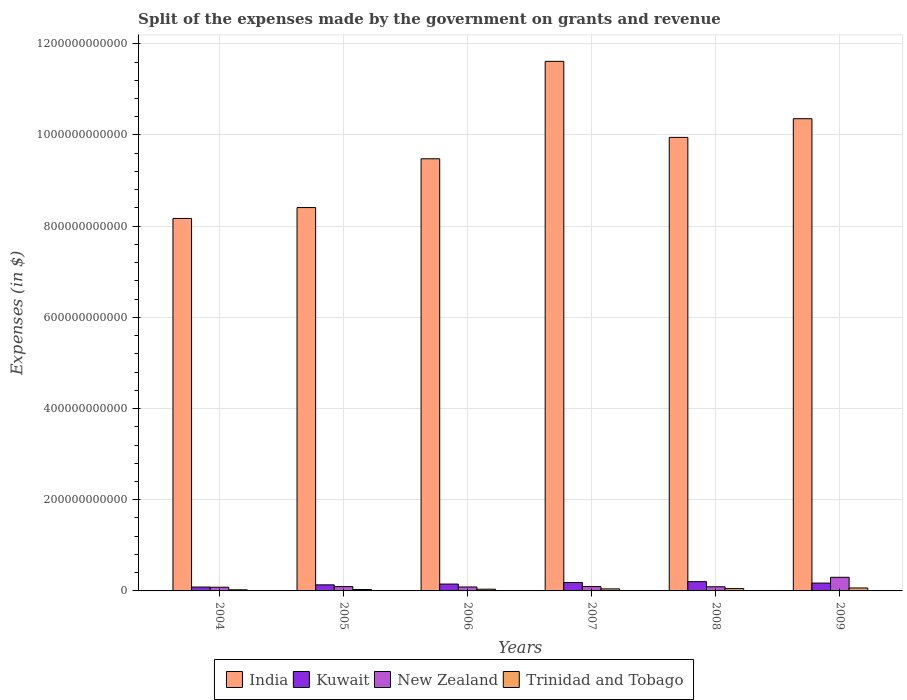How many groups of bars are there?
Provide a short and direct response. 6. How many bars are there on the 1st tick from the left?
Your answer should be very brief. 4. In how many cases, is the number of bars for a given year not equal to the number of legend labels?
Your response must be concise. 0. What is the expenses made by the government on grants and revenue in Kuwait in 2009?
Your answer should be very brief. 1.72e+1. Across all years, what is the maximum expenses made by the government on grants and revenue in India?
Your answer should be compact. 1.16e+12. Across all years, what is the minimum expenses made by the government on grants and revenue in Trinidad and Tobago?
Provide a short and direct response. 2.43e+09. In which year was the expenses made by the government on grants and revenue in Kuwait minimum?
Provide a succinct answer. 2004. What is the total expenses made by the government on grants and revenue in India in the graph?
Ensure brevity in your answer.  5.80e+12. What is the difference between the expenses made by the government on grants and revenue in New Zealand in 2005 and that in 2007?
Your answer should be compact. -1.03e+08. What is the difference between the expenses made by the government on grants and revenue in Kuwait in 2008 and the expenses made by the government on grants and revenue in India in 2009?
Offer a terse response. -1.02e+12. What is the average expenses made by the government on grants and revenue in India per year?
Ensure brevity in your answer.  9.66e+11. In the year 2004, what is the difference between the expenses made by the government on grants and revenue in Trinidad and Tobago and expenses made by the government on grants and revenue in India?
Offer a very short reply. -8.14e+11. What is the ratio of the expenses made by the government on grants and revenue in Trinidad and Tobago in 2005 to that in 2008?
Your response must be concise. 0.6. Is the difference between the expenses made by the government on grants and revenue in Trinidad and Tobago in 2004 and 2009 greater than the difference between the expenses made by the government on grants and revenue in India in 2004 and 2009?
Keep it short and to the point. Yes. What is the difference between the highest and the second highest expenses made by the government on grants and revenue in Kuwait?
Your response must be concise. 1.98e+09. What is the difference between the highest and the lowest expenses made by the government on grants and revenue in Kuwait?
Give a very brief answer. 1.19e+1. In how many years, is the expenses made by the government on grants and revenue in Kuwait greater than the average expenses made by the government on grants and revenue in Kuwait taken over all years?
Your response must be concise. 3. Is the sum of the expenses made by the government on grants and revenue in New Zealand in 2005 and 2008 greater than the maximum expenses made by the government on grants and revenue in India across all years?
Offer a terse response. No. Is it the case that in every year, the sum of the expenses made by the government on grants and revenue in Kuwait and expenses made by the government on grants and revenue in India is greater than the sum of expenses made by the government on grants and revenue in New Zealand and expenses made by the government on grants and revenue in Trinidad and Tobago?
Your response must be concise. No. What does the 2nd bar from the left in 2006 represents?
Give a very brief answer. Kuwait. What does the 2nd bar from the right in 2006 represents?
Offer a very short reply. New Zealand. What is the difference between two consecutive major ticks on the Y-axis?
Provide a short and direct response. 2.00e+11. Does the graph contain any zero values?
Offer a very short reply. No. Does the graph contain grids?
Keep it short and to the point. Yes. Where does the legend appear in the graph?
Give a very brief answer. Bottom center. What is the title of the graph?
Give a very brief answer. Split of the expenses made by the government on grants and revenue. Does "Netherlands" appear as one of the legend labels in the graph?
Offer a terse response. No. What is the label or title of the Y-axis?
Your answer should be very brief. Expenses (in $). What is the Expenses (in $) of India in 2004?
Provide a succinct answer. 8.17e+11. What is the Expenses (in $) in Kuwait in 2004?
Give a very brief answer. 8.50e+09. What is the Expenses (in $) in New Zealand in 2004?
Provide a succinct answer. 8.09e+09. What is the Expenses (in $) in Trinidad and Tobago in 2004?
Your answer should be very brief. 2.43e+09. What is the Expenses (in $) in India in 2005?
Offer a terse response. 8.41e+11. What is the Expenses (in $) of Kuwait in 2005?
Give a very brief answer. 1.33e+1. What is the Expenses (in $) in New Zealand in 2005?
Your response must be concise. 9.45e+09. What is the Expenses (in $) of Trinidad and Tobago in 2005?
Offer a terse response. 3.06e+09. What is the Expenses (in $) of India in 2006?
Keep it short and to the point. 9.48e+11. What is the Expenses (in $) of Kuwait in 2006?
Provide a succinct answer. 1.50e+1. What is the Expenses (in $) of New Zealand in 2006?
Give a very brief answer. 8.64e+09. What is the Expenses (in $) in Trinidad and Tobago in 2006?
Give a very brief answer. 3.79e+09. What is the Expenses (in $) in India in 2007?
Your response must be concise. 1.16e+12. What is the Expenses (in $) of Kuwait in 2007?
Your answer should be very brief. 1.84e+1. What is the Expenses (in $) of New Zealand in 2007?
Offer a terse response. 9.55e+09. What is the Expenses (in $) of Trinidad and Tobago in 2007?
Your response must be concise. 4.42e+09. What is the Expenses (in $) of India in 2008?
Offer a terse response. 9.95e+11. What is the Expenses (in $) in Kuwait in 2008?
Offer a terse response. 2.04e+1. What is the Expenses (in $) of New Zealand in 2008?
Your answer should be very brief. 9.06e+09. What is the Expenses (in $) of Trinidad and Tobago in 2008?
Provide a succinct answer. 5.11e+09. What is the Expenses (in $) in India in 2009?
Your answer should be very brief. 1.04e+12. What is the Expenses (in $) in Kuwait in 2009?
Offer a very short reply. 1.72e+1. What is the Expenses (in $) in New Zealand in 2009?
Provide a succinct answer. 2.99e+1. What is the Expenses (in $) in Trinidad and Tobago in 2009?
Make the answer very short. 6.45e+09. Across all years, what is the maximum Expenses (in $) of India?
Your answer should be very brief. 1.16e+12. Across all years, what is the maximum Expenses (in $) of Kuwait?
Make the answer very short. 2.04e+1. Across all years, what is the maximum Expenses (in $) in New Zealand?
Your response must be concise. 2.99e+1. Across all years, what is the maximum Expenses (in $) of Trinidad and Tobago?
Provide a short and direct response. 6.45e+09. Across all years, what is the minimum Expenses (in $) of India?
Your response must be concise. 8.17e+11. Across all years, what is the minimum Expenses (in $) of Kuwait?
Your answer should be compact. 8.50e+09. Across all years, what is the minimum Expenses (in $) of New Zealand?
Your response must be concise. 8.09e+09. Across all years, what is the minimum Expenses (in $) of Trinidad and Tobago?
Keep it short and to the point. 2.43e+09. What is the total Expenses (in $) in India in the graph?
Your answer should be compact. 5.80e+12. What is the total Expenses (in $) of Kuwait in the graph?
Keep it short and to the point. 9.28e+1. What is the total Expenses (in $) of New Zealand in the graph?
Your response must be concise. 7.46e+1. What is the total Expenses (in $) in Trinidad and Tobago in the graph?
Provide a succinct answer. 2.53e+1. What is the difference between the Expenses (in $) in India in 2004 and that in 2005?
Your answer should be compact. -2.38e+1. What is the difference between the Expenses (in $) of Kuwait in 2004 and that in 2005?
Your response must be concise. -4.81e+09. What is the difference between the Expenses (in $) in New Zealand in 2004 and that in 2005?
Offer a very short reply. -1.36e+09. What is the difference between the Expenses (in $) in Trinidad and Tobago in 2004 and that in 2005?
Offer a terse response. -6.26e+08. What is the difference between the Expenses (in $) in India in 2004 and that in 2006?
Provide a short and direct response. -1.31e+11. What is the difference between the Expenses (in $) in Kuwait in 2004 and that in 2006?
Your answer should be very brief. -6.51e+09. What is the difference between the Expenses (in $) of New Zealand in 2004 and that in 2006?
Provide a short and direct response. -5.56e+08. What is the difference between the Expenses (in $) of Trinidad and Tobago in 2004 and that in 2006?
Keep it short and to the point. -1.36e+09. What is the difference between the Expenses (in $) of India in 2004 and that in 2007?
Offer a terse response. -3.45e+11. What is the difference between the Expenses (in $) in Kuwait in 2004 and that in 2007?
Offer a very short reply. -9.89e+09. What is the difference between the Expenses (in $) in New Zealand in 2004 and that in 2007?
Your response must be concise. -1.46e+09. What is the difference between the Expenses (in $) of Trinidad and Tobago in 2004 and that in 2007?
Make the answer very short. -1.99e+09. What is the difference between the Expenses (in $) of India in 2004 and that in 2008?
Ensure brevity in your answer.  -1.78e+11. What is the difference between the Expenses (in $) in Kuwait in 2004 and that in 2008?
Make the answer very short. -1.19e+1. What is the difference between the Expenses (in $) in New Zealand in 2004 and that in 2008?
Keep it short and to the point. -9.72e+08. What is the difference between the Expenses (in $) in Trinidad and Tobago in 2004 and that in 2008?
Ensure brevity in your answer.  -2.68e+09. What is the difference between the Expenses (in $) in India in 2004 and that in 2009?
Provide a short and direct response. -2.19e+11. What is the difference between the Expenses (in $) in Kuwait in 2004 and that in 2009?
Offer a terse response. -8.67e+09. What is the difference between the Expenses (in $) in New Zealand in 2004 and that in 2009?
Make the answer very short. -2.18e+1. What is the difference between the Expenses (in $) in Trinidad and Tobago in 2004 and that in 2009?
Provide a short and direct response. -4.02e+09. What is the difference between the Expenses (in $) in India in 2005 and that in 2006?
Your answer should be compact. -1.07e+11. What is the difference between the Expenses (in $) of Kuwait in 2005 and that in 2006?
Offer a very short reply. -1.70e+09. What is the difference between the Expenses (in $) in New Zealand in 2005 and that in 2006?
Your response must be concise. 8.05e+08. What is the difference between the Expenses (in $) in Trinidad and Tobago in 2005 and that in 2006?
Provide a succinct answer. -7.30e+08. What is the difference between the Expenses (in $) in India in 2005 and that in 2007?
Give a very brief answer. -3.21e+11. What is the difference between the Expenses (in $) in Kuwait in 2005 and that in 2007?
Your response must be concise. -5.08e+09. What is the difference between the Expenses (in $) of New Zealand in 2005 and that in 2007?
Offer a terse response. -1.03e+08. What is the difference between the Expenses (in $) of Trinidad and Tobago in 2005 and that in 2007?
Make the answer very short. -1.36e+09. What is the difference between the Expenses (in $) of India in 2005 and that in 2008?
Offer a very short reply. -1.54e+11. What is the difference between the Expenses (in $) in Kuwait in 2005 and that in 2008?
Make the answer very short. -7.06e+09. What is the difference between the Expenses (in $) of New Zealand in 2005 and that in 2008?
Ensure brevity in your answer.  3.89e+08. What is the difference between the Expenses (in $) in Trinidad and Tobago in 2005 and that in 2008?
Provide a succinct answer. -2.05e+09. What is the difference between the Expenses (in $) of India in 2005 and that in 2009?
Provide a short and direct response. -1.95e+11. What is the difference between the Expenses (in $) in Kuwait in 2005 and that in 2009?
Make the answer very short. -3.86e+09. What is the difference between the Expenses (in $) in New Zealand in 2005 and that in 2009?
Offer a very short reply. -2.04e+1. What is the difference between the Expenses (in $) of Trinidad and Tobago in 2005 and that in 2009?
Offer a very short reply. -3.40e+09. What is the difference between the Expenses (in $) of India in 2006 and that in 2007?
Your answer should be compact. -2.14e+11. What is the difference between the Expenses (in $) in Kuwait in 2006 and that in 2007?
Your response must be concise. -3.38e+09. What is the difference between the Expenses (in $) of New Zealand in 2006 and that in 2007?
Offer a terse response. -9.08e+08. What is the difference between the Expenses (in $) of Trinidad and Tobago in 2006 and that in 2007?
Provide a short and direct response. -6.34e+08. What is the difference between the Expenses (in $) in India in 2006 and that in 2008?
Provide a short and direct response. -4.69e+1. What is the difference between the Expenses (in $) in Kuwait in 2006 and that in 2008?
Your answer should be very brief. -5.36e+09. What is the difference between the Expenses (in $) of New Zealand in 2006 and that in 2008?
Your response must be concise. -4.16e+08. What is the difference between the Expenses (in $) in Trinidad and Tobago in 2006 and that in 2008?
Offer a very short reply. -1.32e+09. What is the difference between the Expenses (in $) of India in 2006 and that in 2009?
Your answer should be compact. -8.79e+1. What is the difference between the Expenses (in $) of Kuwait in 2006 and that in 2009?
Your answer should be very brief. -2.16e+09. What is the difference between the Expenses (in $) of New Zealand in 2006 and that in 2009?
Your response must be concise. -2.12e+1. What is the difference between the Expenses (in $) in Trinidad and Tobago in 2006 and that in 2009?
Your response must be concise. -2.66e+09. What is the difference between the Expenses (in $) of India in 2007 and that in 2008?
Your answer should be compact. 1.67e+11. What is the difference between the Expenses (in $) of Kuwait in 2007 and that in 2008?
Provide a succinct answer. -1.98e+09. What is the difference between the Expenses (in $) of New Zealand in 2007 and that in 2008?
Your response must be concise. 4.92e+08. What is the difference between the Expenses (in $) in Trinidad and Tobago in 2007 and that in 2008?
Offer a terse response. -6.86e+08. What is the difference between the Expenses (in $) of India in 2007 and that in 2009?
Make the answer very short. 1.26e+11. What is the difference between the Expenses (in $) of Kuwait in 2007 and that in 2009?
Ensure brevity in your answer.  1.22e+09. What is the difference between the Expenses (in $) in New Zealand in 2007 and that in 2009?
Offer a terse response. -2.03e+1. What is the difference between the Expenses (in $) of Trinidad and Tobago in 2007 and that in 2009?
Ensure brevity in your answer.  -2.03e+09. What is the difference between the Expenses (in $) of India in 2008 and that in 2009?
Ensure brevity in your answer.  -4.10e+1. What is the difference between the Expenses (in $) in Kuwait in 2008 and that in 2009?
Keep it short and to the point. 3.20e+09. What is the difference between the Expenses (in $) of New Zealand in 2008 and that in 2009?
Your answer should be compact. -2.08e+1. What is the difference between the Expenses (in $) of Trinidad and Tobago in 2008 and that in 2009?
Keep it short and to the point. -1.34e+09. What is the difference between the Expenses (in $) of India in 2004 and the Expenses (in $) of Kuwait in 2005?
Your answer should be very brief. 8.04e+11. What is the difference between the Expenses (in $) of India in 2004 and the Expenses (in $) of New Zealand in 2005?
Give a very brief answer. 8.07e+11. What is the difference between the Expenses (in $) of India in 2004 and the Expenses (in $) of Trinidad and Tobago in 2005?
Provide a succinct answer. 8.14e+11. What is the difference between the Expenses (in $) of Kuwait in 2004 and the Expenses (in $) of New Zealand in 2005?
Make the answer very short. -9.43e+08. What is the difference between the Expenses (in $) of Kuwait in 2004 and the Expenses (in $) of Trinidad and Tobago in 2005?
Ensure brevity in your answer.  5.45e+09. What is the difference between the Expenses (in $) in New Zealand in 2004 and the Expenses (in $) in Trinidad and Tobago in 2005?
Offer a terse response. 5.03e+09. What is the difference between the Expenses (in $) in India in 2004 and the Expenses (in $) in Kuwait in 2006?
Provide a short and direct response. 8.02e+11. What is the difference between the Expenses (in $) in India in 2004 and the Expenses (in $) in New Zealand in 2006?
Make the answer very short. 8.08e+11. What is the difference between the Expenses (in $) in India in 2004 and the Expenses (in $) in Trinidad and Tobago in 2006?
Your response must be concise. 8.13e+11. What is the difference between the Expenses (in $) of Kuwait in 2004 and the Expenses (in $) of New Zealand in 2006?
Provide a short and direct response. -1.38e+08. What is the difference between the Expenses (in $) of Kuwait in 2004 and the Expenses (in $) of Trinidad and Tobago in 2006?
Ensure brevity in your answer.  4.71e+09. What is the difference between the Expenses (in $) in New Zealand in 2004 and the Expenses (in $) in Trinidad and Tobago in 2006?
Ensure brevity in your answer.  4.30e+09. What is the difference between the Expenses (in $) in India in 2004 and the Expenses (in $) in Kuwait in 2007?
Your answer should be very brief. 7.99e+11. What is the difference between the Expenses (in $) in India in 2004 and the Expenses (in $) in New Zealand in 2007?
Ensure brevity in your answer.  8.07e+11. What is the difference between the Expenses (in $) in India in 2004 and the Expenses (in $) in Trinidad and Tobago in 2007?
Your response must be concise. 8.12e+11. What is the difference between the Expenses (in $) in Kuwait in 2004 and the Expenses (in $) in New Zealand in 2007?
Offer a very short reply. -1.05e+09. What is the difference between the Expenses (in $) of Kuwait in 2004 and the Expenses (in $) of Trinidad and Tobago in 2007?
Your answer should be very brief. 4.08e+09. What is the difference between the Expenses (in $) in New Zealand in 2004 and the Expenses (in $) in Trinidad and Tobago in 2007?
Ensure brevity in your answer.  3.66e+09. What is the difference between the Expenses (in $) of India in 2004 and the Expenses (in $) of Kuwait in 2008?
Your response must be concise. 7.97e+11. What is the difference between the Expenses (in $) in India in 2004 and the Expenses (in $) in New Zealand in 2008?
Give a very brief answer. 8.08e+11. What is the difference between the Expenses (in $) of India in 2004 and the Expenses (in $) of Trinidad and Tobago in 2008?
Give a very brief answer. 8.12e+11. What is the difference between the Expenses (in $) of Kuwait in 2004 and the Expenses (in $) of New Zealand in 2008?
Offer a terse response. -5.54e+08. What is the difference between the Expenses (in $) in Kuwait in 2004 and the Expenses (in $) in Trinidad and Tobago in 2008?
Provide a short and direct response. 3.39e+09. What is the difference between the Expenses (in $) of New Zealand in 2004 and the Expenses (in $) of Trinidad and Tobago in 2008?
Keep it short and to the point. 2.98e+09. What is the difference between the Expenses (in $) of India in 2004 and the Expenses (in $) of Kuwait in 2009?
Ensure brevity in your answer.  8.00e+11. What is the difference between the Expenses (in $) in India in 2004 and the Expenses (in $) in New Zealand in 2009?
Give a very brief answer. 7.87e+11. What is the difference between the Expenses (in $) in India in 2004 and the Expenses (in $) in Trinidad and Tobago in 2009?
Provide a short and direct response. 8.10e+11. What is the difference between the Expenses (in $) in Kuwait in 2004 and the Expenses (in $) in New Zealand in 2009?
Offer a terse response. -2.14e+1. What is the difference between the Expenses (in $) in Kuwait in 2004 and the Expenses (in $) in Trinidad and Tobago in 2009?
Give a very brief answer. 2.05e+09. What is the difference between the Expenses (in $) of New Zealand in 2004 and the Expenses (in $) of Trinidad and Tobago in 2009?
Offer a terse response. 1.63e+09. What is the difference between the Expenses (in $) in India in 2005 and the Expenses (in $) in Kuwait in 2006?
Make the answer very short. 8.26e+11. What is the difference between the Expenses (in $) of India in 2005 and the Expenses (in $) of New Zealand in 2006?
Provide a succinct answer. 8.32e+11. What is the difference between the Expenses (in $) of India in 2005 and the Expenses (in $) of Trinidad and Tobago in 2006?
Your answer should be very brief. 8.37e+11. What is the difference between the Expenses (in $) of Kuwait in 2005 and the Expenses (in $) of New Zealand in 2006?
Ensure brevity in your answer.  4.67e+09. What is the difference between the Expenses (in $) in Kuwait in 2005 and the Expenses (in $) in Trinidad and Tobago in 2006?
Give a very brief answer. 9.52e+09. What is the difference between the Expenses (in $) of New Zealand in 2005 and the Expenses (in $) of Trinidad and Tobago in 2006?
Your answer should be very brief. 5.66e+09. What is the difference between the Expenses (in $) in India in 2005 and the Expenses (in $) in Kuwait in 2007?
Your answer should be compact. 8.22e+11. What is the difference between the Expenses (in $) in India in 2005 and the Expenses (in $) in New Zealand in 2007?
Your answer should be very brief. 8.31e+11. What is the difference between the Expenses (in $) of India in 2005 and the Expenses (in $) of Trinidad and Tobago in 2007?
Make the answer very short. 8.36e+11. What is the difference between the Expenses (in $) in Kuwait in 2005 and the Expenses (in $) in New Zealand in 2007?
Your answer should be very brief. 3.76e+09. What is the difference between the Expenses (in $) of Kuwait in 2005 and the Expenses (in $) of Trinidad and Tobago in 2007?
Keep it short and to the point. 8.89e+09. What is the difference between the Expenses (in $) in New Zealand in 2005 and the Expenses (in $) in Trinidad and Tobago in 2007?
Provide a succinct answer. 5.02e+09. What is the difference between the Expenses (in $) in India in 2005 and the Expenses (in $) in Kuwait in 2008?
Provide a short and direct response. 8.20e+11. What is the difference between the Expenses (in $) of India in 2005 and the Expenses (in $) of New Zealand in 2008?
Your answer should be very brief. 8.32e+11. What is the difference between the Expenses (in $) in India in 2005 and the Expenses (in $) in Trinidad and Tobago in 2008?
Keep it short and to the point. 8.36e+11. What is the difference between the Expenses (in $) of Kuwait in 2005 and the Expenses (in $) of New Zealand in 2008?
Your answer should be very brief. 4.26e+09. What is the difference between the Expenses (in $) of Kuwait in 2005 and the Expenses (in $) of Trinidad and Tobago in 2008?
Provide a succinct answer. 8.20e+09. What is the difference between the Expenses (in $) in New Zealand in 2005 and the Expenses (in $) in Trinidad and Tobago in 2008?
Your answer should be very brief. 4.34e+09. What is the difference between the Expenses (in $) of India in 2005 and the Expenses (in $) of Kuwait in 2009?
Offer a terse response. 8.24e+11. What is the difference between the Expenses (in $) in India in 2005 and the Expenses (in $) in New Zealand in 2009?
Offer a very short reply. 8.11e+11. What is the difference between the Expenses (in $) of India in 2005 and the Expenses (in $) of Trinidad and Tobago in 2009?
Make the answer very short. 8.34e+11. What is the difference between the Expenses (in $) of Kuwait in 2005 and the Expenses (in $) of New Zealand in 2009?
Your answer should be compact. -1.65e+1. What is the difference between the Expenses (in $) in Kuwait in 2005 and the Expenses (in $) in Trinidad and Tobago in 2009?
Your answer should be compact. 6.86e+09. What is the difference between the Expenses (in $) in New Zealand in 2005 and the Expenses (in $) in Trinidad and Tobago in 2009?
Offer a very short reply. 2.99e+09. What is the difference between the Expenses (in $) of India in 2006 and the Expenses (in $) of Kuwait in 2007?
Provide a short and direct response. 9.29e+11. What is the difference between the Expenses (in $) of India in 2006 and the Expenses (in $) of New Zealand in 2007?
Offer a terse response. 9.38e+11. What is the difference between the Expenses (in $) of India in 2006 and the Expenses (in $) of Trinidad and Tobago in 2007?
Offer a terse response. 9.43e+11. What is the difference between the Expenses (in $) in Kuwait in 2006 and the Expenses (in $) in New Zealand in 2007?
Make the answer very short. 5.47e+09. What is the difference between the Expenses (in $) of Kuwait in 2006 and the Expenses (in $) of Trinidad and Tobago in 2007?
Keep it short and to the point. 1.06e+1. What is the difference between the Expenses (in $) of New Zealand in 2006 and the Expenses (in $) of Trinidad and Tobago in 2007?
Provide a short and direct response. 4.22e+09. What is the difference between the Expenses (in $) in India in 2006 and the Expenses (in $) in Kuwait in 2008?
Keep it short and to the point. 9.27e+11. What is the difference between the Expenses (in $) of India in 2006 and the Expenses (in $) of New Zealand in 2008?
Ensure brevity in your answer.  9.39e+11. What is the difference between the Expenses (in $) in India in 2006 and the Expenses (in $) in Trinidad and Tobago in 2008?
Provide a short and direct response. 9.43e+11. What is the difference between the Expenses (in $) in Kuwait in 2006 and the Expenses (in $) in New Zealand in 2008?
Make the answer very short. 5.96e+09. What is the difference between the Expenses (in $) in Kuwait in 2006 and the Expenses (in $) in Trinidad and Tobago in 2008?
Your answer should be compact. 9.91e+09. What is the difference between the Expenses (in $) of New Zealand in 2006 and the Expenses (in $) of Trinidad and Tobago in 2008?
Keep it short and to the point. 3.53e+09. What is the difference between the Expenses (in $) in India in 2006 and the Expenses (in $) in Kuwait in 2009?
Give a very brief answer. 9.31e+11. What is the difference between the Expenses (in $) in India in 2006 and the Expenses (in $) in New Zealand in 2009?
Make the answer very short. 9.18e+11. What is the difference between the Expenses (in $) of India in 2006 and the Expenses (in $) of Trinidad and Tobago in 2009?
Provide a short and direct response. 9.41e+11. What is the difference between the Expenses (in $) of Kuwait in 2006 and the Expenses (in $) of New Zealand in 2009?
Your answer should be very brief. -1.48e+1. What is the difference between the Expenses (in $) in Kuwait in 2006 and the Expenses (in $) in Trinidad and Tobago in 2009?
Your response must be concise. 8.56e+09. What is the difference between the Expenses (in $) in New Zealand in 2006 and the Expenses (in $) in Trinidad and Tobago in 2009?
Ensure brevity in your answer.  2.19e+09. What is the difference between the Expenses (in $) of India in 2007 and the Expenses (in $) of Kuwait in 2008?
Keep it short and to the point. 1.14e+12. What is the difference between the Expenses (in $) of India in 2007 and the Expenses (in $) of New Zealand in 2008?
Keep it short and to the point. 1.15e+12. What is the difference between the Expenses (in $) in India in 2007 and the Expenses (in $) in Trinidad and Tobago in 2008?
Provide a succinct answer. 1.16e+12. What is the difference between the Expenses (in $) of Kuwait in 2007 and the Expenses (in $) of New Zealand in 2008?
Provide a short and direct response. 9.33e+09. What is the difference between the Expenses (in $) in Kuwait in 2007 and the Expenses (in $) in Trinidad and Tobago in 2008?
Your response must be concise. 1.33e+1. What is the difference between the Expenses (in $) in New Zealand in 2007 and the Expenses (in $) in Trinidad and Tobago in 2008?
Your response must be concise. 4.44e+09. What is the difference between the Expenses (in $) of India in 2007 and the Expenses (in $) of Kuwait in 2009?
Provide a succinct answer. 1.14e+12. What is the difference between the Expenses (in $) in India in 2007 and the Expenses (in $) in New Zealand in 2009?
Make the answer very short. 1.13e+12. What is the difference between the Expenses (in $) of India in 2007 and the Expenses (in $) of Trinidad and Tobago in 2009?
Provide a short and direct response. 1.15e+12. What is the difference between the Expenses (in $) in Kuwait in 2007 and the Expenses (in $) in New Zealand in 2009?
Make the answer very short. -1.15e+1. What is the difference between the Expenses (in $) in Kuwait in 2007 and the Expenses (in $) in Trinidad and Tobago in 2009?
Ensure brevity in your answer.  1.19e+1. What is the difference between the Expenses (in $) in New Zealand in 2007 and the Expenses (in $) in Trinidad and Tobago in 2009?
Ensure brevity in your answer.  3.10e+09. What is the difference between the Expenses (in $) in India in 2008 and the Expenses (in $) in Kuwait in 2009?
Your response must be concise. 9.77e+11. What is the difference between the Expenses (in $) in India in 2008 and the Expenses (in $) in New Zealand in 2009?
Keep it short and to the point. 9.65e+11. What is the difference between the Expenses (in $) in India in 2008 and the Expenses (in $) in Trinidad and Tobago in 2009?
Your answer should be very brief. 9.88e+11. What is the difference between the Expenses (in $) of Kuwait in 2008 and the Expenses (in $) of New Zealand in 2009?
Offer a very short reply. -9.48e+09. What is the difference between the Expenses (in $) of Kuwait in 2008 and the Expenses (in $) of Trinidad and Tobago in 2009?
Offer a very short reply. 1.39e+1. What is the difference between the Expenses (in $) in New Zealand in 2008 and the Expenses (in $) in Trinidad and Tobago in 2009?
Your answer should be very brief. 2.60e+09. What is the average Expenses (in $) in India per year?
Offer a terse response. 9.66e+11. What is the average Expenses (in $) of Kuwait per year?
Your answer should be very brief. 1.55e+1. What is the average Expenses (in $) in New Zealand per year?
Offer a terse response. 1.24e+1. What is the average Expenses (in $) of Trinidad and Tobago per year?
Offer a terse response. 4.21e+09. In the year 2004, what is the difference between the Expenses (in $) of India and Expenses (in $) of Kuwait?
Offer a terse response. 8.08e+11. In the year 2004, what is the difference between the Expenses (in $) of India and Expenses (in $) of New Zealand?
Keep it short and to the point. 8.09e+11. In the year 2004, what is the difference between the Expenses (in $) of India and Expenses (in $) of Trinidad and Tobago?
Offer a very short reply. 8.14e+11. In the year 2004, what is the difference between the Expenses (in $) of Kuwait and Expenses (in $) of New Zealand?
Your response must be concise. 4.18e+08. In the year 2004, what is the difference between the Expenses (in $) in Kuwait and Expenses (in $) in Trinidad and Tobago?
Keep it short and to the point. 6.07e+09. In the year 2004, what is the difference between the Expenses (in $) of New Zealand and Expenses (in $) of Trinidad and Tobago?
Offer a terse response. 5.65e+09. In the year 2005, what is the difference between the Expenses (in $) in India and Expenses (in $) in Kuwait?
Your answer should be very brief. 8.27e+11. In the year 2005, what is the difference between the Expenses (in $) of India and Expenses (in $) of New Zealand?
Keep it short and to the point. 8.31e+11. In the year 2005, what is the difference between the Expenses (in $) in India and Expenses (in $) in Trinidad and Tobago?
Make the answer very short. 8.38e+11. In the year 2005, what is the difference between the Expenses (in $) in Kuwait and Expenses (in $) in New Zealand?
Ensure brevity in your answer.  3.87e+09. In the year 2005, what is the difference between the Expenses (in $) in Kuwait and Expenses (in $) in Trinidad and Tobago?
Keep it short and to the point. 1.03e+1. In the year 2005, what is the difference between the Expenses (in $) of New Zealand and Expenses (in $) of Trinidad and Tobago?
Make the answer very short. 6.39e+09. In the year 2006, what is the difference between the Expenses (in $) in India and Expenses (in $) in Kuwait?
Provide a short and direct response. 9.33e+11. In the year 2006, what is the difference between the Expenses (in $) of India and Expenses (in $) of New Zealand?
Your response must be concise. 9.39e+11. In the year 2006, what is the difference between the Expenses (in $) in India and Expenses (in $) in Trinidad and Tobago?
Your answer should be very brief. 9.44e+11. In the year 2006, what is the difference between the Expenses (in $) of Kuwait and Expenses (in $) of New Zealand?
Provide a short and direct response. 6.38e+09. In the year 2006, what is the difference between the Expenses (in $) in Kuwait and Expenses (in $) in Trinidad and Tobago?
Your answer should be very brief. 1.12e+1. In the year 2006, what is the difference between the Expenses (in $) of New Zealand and Expenses (in $) of Trinidad and Tobago?
Provide a succinct answer. 4.85e+09. In the year 2007, what is the difference between the Expenses (in $) in India and Expenses (in $) in Kuwait?
Your answer should be compact. 1.14e+12. In the year 2007, what is the difference between the Expenses (in $) in India and Expenses (in $) in New Zealand?
Your answer should be compact. 1.15e+12. In the year 2007, what is the difference between the Expenses (in $) in India and Expenses (in $) in Trinidad and Tobago?
Your answer should be very brief. 1.16e+12. In the year 2007, what is the difference between the Expenses (in $) in Kuwait and Expenses (in $) in New Zealand?
Your answer should be compact. 8.84e+09. In the year 2007, what is the difference between the Expenses (in $) of Kuwait and Expenses (in $) of Trinidad and Tobago?
Provide a short and direct response. 1.40e+1. In the year 2007, what is the difference between the Expenses (in $) in New Zealand and Expenses (in $) in Trinidad and Tobago?
Make the answer very short. 5.13e+09. In the year 2008, what is the difference between the Expenses (in $) in India and Expenses (in $) in Kuwait?
Offer a very short reply. 9.74e+11. In the year 2008, what is the difference between the Expenses (in $) in India and Expenses (in $) in New Zealand?
Make the answer very short. 9.86e+11. In the year 2008, what is the difference between the Expenses (in $) of India and Expenses (in $) of Trinidad and Tobago?
Offer a very short reply. 9.90e+11. In the year 2008, what is the difference between the Expenses (in $) in Kuwait and Expenses (in $) in New Zealand?
Your response must be concise. 1.13e+1. In the year 2008, what is the difference between the Expenses (in $) of Kuwait and Expenses (in $) of Trinidad and Tobago?
Your answer should be very brief. 1.53e+1. In the year 2008, what is the difference between the Expenses (in $) of New Zealand and Expenses (in $) of Trinidad and Tobago?
Offer a terse response. 3.95e+09. In the year 2009, what is the difference between the Expenses (in $) of India and Expenses (in $) of Kuwait?
Offer a very short reply. 1.02e+12. In the year 2009, what is the difference between the Expenses (in $) in India and Expenses (in $) in New Zealand?
Make the answer very short. 1.01e+12. In the year 2009, what is the difference between the Expenses (in $) in India and Expenses (in $) in Trinidad and Tobago?
Give a very brief answer. 1.03e+12. In the year 2009, what is the difference between the Expenses (in $) of Kuwait and Expenses (in $) of New Zealand?
Keep it short and to the point. -1.27e+1. In the year 2009, what is the difference between the Expenses (in $) of Kuwait and Expenses (in $) of Trinidad and Tobago?
Give a very brief answer. 1.07e+1. In the year 2009, what is the difference between the Expenses (in $) of New Zealand and Expenses (in $) of Trinidad and Tobago?
Your answer should be very brief. 2.34e+1. What is the ratio of the Expenses (in $) of India in 2004 to that in 2005?
Make the answer very short. 0.97. What is the ratio of the Expenses (in $) of Kuwait in 2004 to that in 2005?
Keep it short and to the point. 0.64. What is the ratio of the Expenses (in $) in New Zealand in 2004 to that in 2005?
Provide a short and direct response. 0.86. What is the ratio of the Expenses (in $) of Trinidad and Tobago in 2004 to that in 2005?
Your response must be concise. 0.8. What is the ratio of the Expenses (in $) of India in 2004 to that in 2006?
Offer a very short reply. 0.86. What is the ratio of the Expenses (in $) in Kuwait in 2004 to that in 2006?
Give a very brief answer. 0.57. What is the ratio of the Expenses (in $) in New Zealand in 2004 to that in 2006?
Make the answer very short. 0.94. What is the ratio of the Expenses (in $) in Trinidad and Tobago in 2004 to that in 2006?
Your response must be concise. 0.64. What is the ratio of the Expenses (in $) of India in 2004 to that in 2007?
Your answer should be compact. 0.7. What is the ratio of the Expenses (in $) of Kuwait in 2004 to that in 2007?
Keep it short and to the point. 0.46. What is the ratio of the Expenses (in $) in New Zealand in 2004 to that in 2007?
Keep it short and to the point. 0.85. What is the ratio of the Expenses (in $) in Trinidad and Tobago in 2004 to that in 2007?
Ensure brevity in your answer.  0.55. What is the ratio of the Expenses (in $) of India in 2004 to that in 2008?
Offer a terse response. 0.82. What is the ratio of the Expenses (in $) of Kuwait in 2004 to that in 2008?
Make the answer very short. 0.42. What is the ratio of the Expenses (in $) of New Zealand in 2004 to that in 2008?
Offer a terse response. 0.89. What is the ratio of the Expenses (in $) in Trinidad and Tobago in 2004 to that in 2008?
Your answer should be compact. 0.48. What is the ratio of the Expenses (in $) in India in 2004 to that in 2009?
Ensure brevity in your answer.  0.79. What is the ratio of the Expenses (in $) of Kuwait in 2004 to that in 2009?
Provide a succinct answer. 0.5. What is the ratio of the Expenses (in $) in New Zealand in 2004 to that in 2009?
Your answer should be very brief. 0.27. What is the ratio of the Expenses (in $) in Trinidad and Tobago in 2004 to that in 2009?
Your answer should be very brief. 0.38. What is the ratio of the Expenses (in $) of India in 2005 to that in 2006?
Provide a short and direct response. 0.89. What is the ratio of the Expenses (in $) of Kuwait in 2005 to that in 2006?
Keep it short and to the point. 0.89. What is the ratio of the Expenses (in $) in New Zealand in 2005 to that in 2006?
Keep it short and to the point. 1.09. What is the ratio of the Expenses (in $) in Trinidad and Tobago in 2005 to that in 2006?
Provide a short and direct response. 0.81. What is the ratio of the Expenses (in $) in India in 2005 to that in 2007?
Keep it short and to the point. 0.72. What is the ratio of the Expenses (in $) in Kuwait in 2005 to that in 2007?
Give a very brief answer. 0.72. What is the ratio of the Expenses (in $) in Trinidad and Tobago in 2005 to that in 2007?
Your answer should be very brief. 0.69. What is the ratio of the Expenses (in $) in India in 2005 to that in 2008?
Provide a short and direct response. 0.85. What is the ratio of the Expenses (in $) of Kuwait in 2005 to that in 2008?
Provide a short and direct response. 0.65. What is the ratio of the Expenses (in $) of New Zealand in 2005 to that in 2008?
Ensure brevity in your answer.  1.04. What is the ratio of the Expenses (in $) of Trinidad and Tobago in 2005 to that in 2008?
Provide a short and direct response. 0.6. What is the ratio of the Expenses (in $) of India in 2005 to that in 2009?
Your answer should be very brief. 0.81. What is the ratio of the Expenses (in $) in Kuwait in 2005 to that in 2009?
Provide a succinct answer. 0.78. What is the ratio of the Expenses (in $) in New Zealand in 2005 to that in 2009?
Keep it short and to the point. 0.32. What is the ratio of the Expenses (in $) in Trinidad and Tobago in 2005 to that in 2009?
Ensure brevity in your answer.  0.47. What is the ratio of the Expenses (in $) in India in 2006 to that in 2007?
Keep it short and to the point. 0.82. What is the ratio of the Expenses (in $) of Kuwait in 2006 to that in 2007?
Provide a short and direct response. 0.82. What is the ratio of the Expenses (in $) of New Zealand in 2006 to that in 2007?
Give a very brief answer. 0.9. What is the ratio of the Expenses (in $) in Trinidad and Tobago in 2006 to that in 2007?
Offer a very short reply. 0.86. What is the ratio of the Expenses (in $) of India in 2006 to that in 2008?
Your answer should be compact. 0.95. What is the ratio of the Expenses (in $) in Kuwait in 2006 to that in 2008?
Your response must be concise. 0.74. What is the ratio of the Expenses (in $) in New Zealand in 2006 to that in 2008?
Offer a very short reply. 0.95. What is the ratio of the Expenses (in $) of Trinidad and Tobago in 2006 to that in 2008?
Make the answer very short. 0.74. What is the ratio of the Expenses (in $) of India in 2006 to that in 2009?
Make the answer very short. 0.92. What is the ratio of the Expenses (in $) in Kuwait in 2006 to that in 2009?
Offer a terse response. 0.87. What is the ratio of the Expenses (in $) of New Zealand in 2006 to that in 2009?
Give a very brief answer. 0.29. What is the ratio of the Expenses (in $) in Trinidad and Tobago in 2006 to that in 2009?
Ensure brevity in your answer.  0.59. What is the ratio of the Expenses (in $) in India in 2007 to that in 2008?
Ensure brevity in your answer.  1.17. What is the ratio of the Expenses (in $) in Kuwait in 2007 to that in 2008?
Provide a short and direct response. 0.9. What is the ratio of the Expenses (in $) in New Zealand in 2007 to that in 2008?
Your answer should be compact. 1.05. What is the ratio of the Expenses (in $) in Trinidad and Tobago in 2007 to that in 2008?
Offer a very short reply. 0.87. What is the ratio of the Expenses (in $) of India in 2007 to that in 2009?
Offer a terse response. 1.12. What is the ratio of the Expenses (in $) in Kuwait in 2007 to that in 2009?
Keep it short and to the point. 1.07. What is the ratio of the Expenses (in $) of New Zealand in 2007 to that in 2009?
Your answer should be very brief. 0.32. What is the ratio of the Expenses (in $) of Trinidad and Tobago in 2007 to that in 2009?
Your answer should be very brief. 0.69. What is the ratio of the Expenses (in $) in India in 2008 to that in 2009?
Keep it short and to the point. 0.96. What is the ratio of the Expenses (in $) of Kuwait in 2008 to that in 2009?
Your response must be concise. 1.19. What is the ratio of the Expenses (in $) of New Zealand in 2008 to that in 2009?
Keep it short and to the point. 0.3. What is the ratio of the Expenses (in $) of Trinidad and Tobago in 2008 to that in 2009?
Your response must be concise. 0.79. What is the difference between the highest and the second highest Expenses (in $) in India?
Provide a succinct answer. 1.26e+11. What is the difference between the highest and the second highest Expenses (in $) of Kuwait?
Make the answer very short. 1.98e+09. What is the difference between the highest and the second highest Expenses (in $) of New Zealand?
Your response must be concise. 2.03e+1. What is the difference between the highest and the second highest Expenses (in $) of Trinidad and Tobago?
Your answer should be very brief. 1.34e+09. What is the difference between the highest and the lowest Expenses (in $) of India?
Provide a short and direct response. 3.45e+11. What is the difference between the highest and the lowest Expenses (in $) in Kuwait?
Ensure brevity in your answer.  1.19e+1. What is the difference between the highest and the lowest Expenses (in $) of New Zealand?
Your answer should be very brief. 2.18e+1. What is the difference between the highest and the lowest Expenses (in $) in Trinidad and Tobago?
Give a very brief answer. 4.02e+09. 